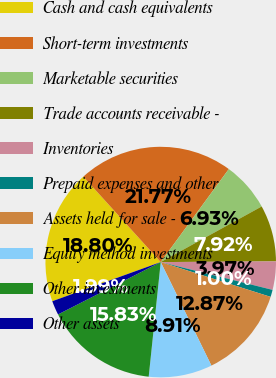Convert chart to OTSL. <chart><loc_0><loc_0><loc_500><loc_500><pie_chart><fcel>Cash and cash equivalents<fcel>Short-term investments<fcel>Marketable securities<fcel>Trade accounts receivable -<fcel>Inventories<fcel>Prepaid expenses and other<fcel>Assets held for sale -<fcel>Equity method investments<fcel>Other investments<fcel>Other assets<nl><fcel>18.8%<fcel>21.77%<fcel>6.93%<fcel>7.92%<fcel>3.97%<fcel>1.0%<fcel>12.87%<fcel>8.91%<fcel>15.83%<fcel>1.99%<nl></chart> 